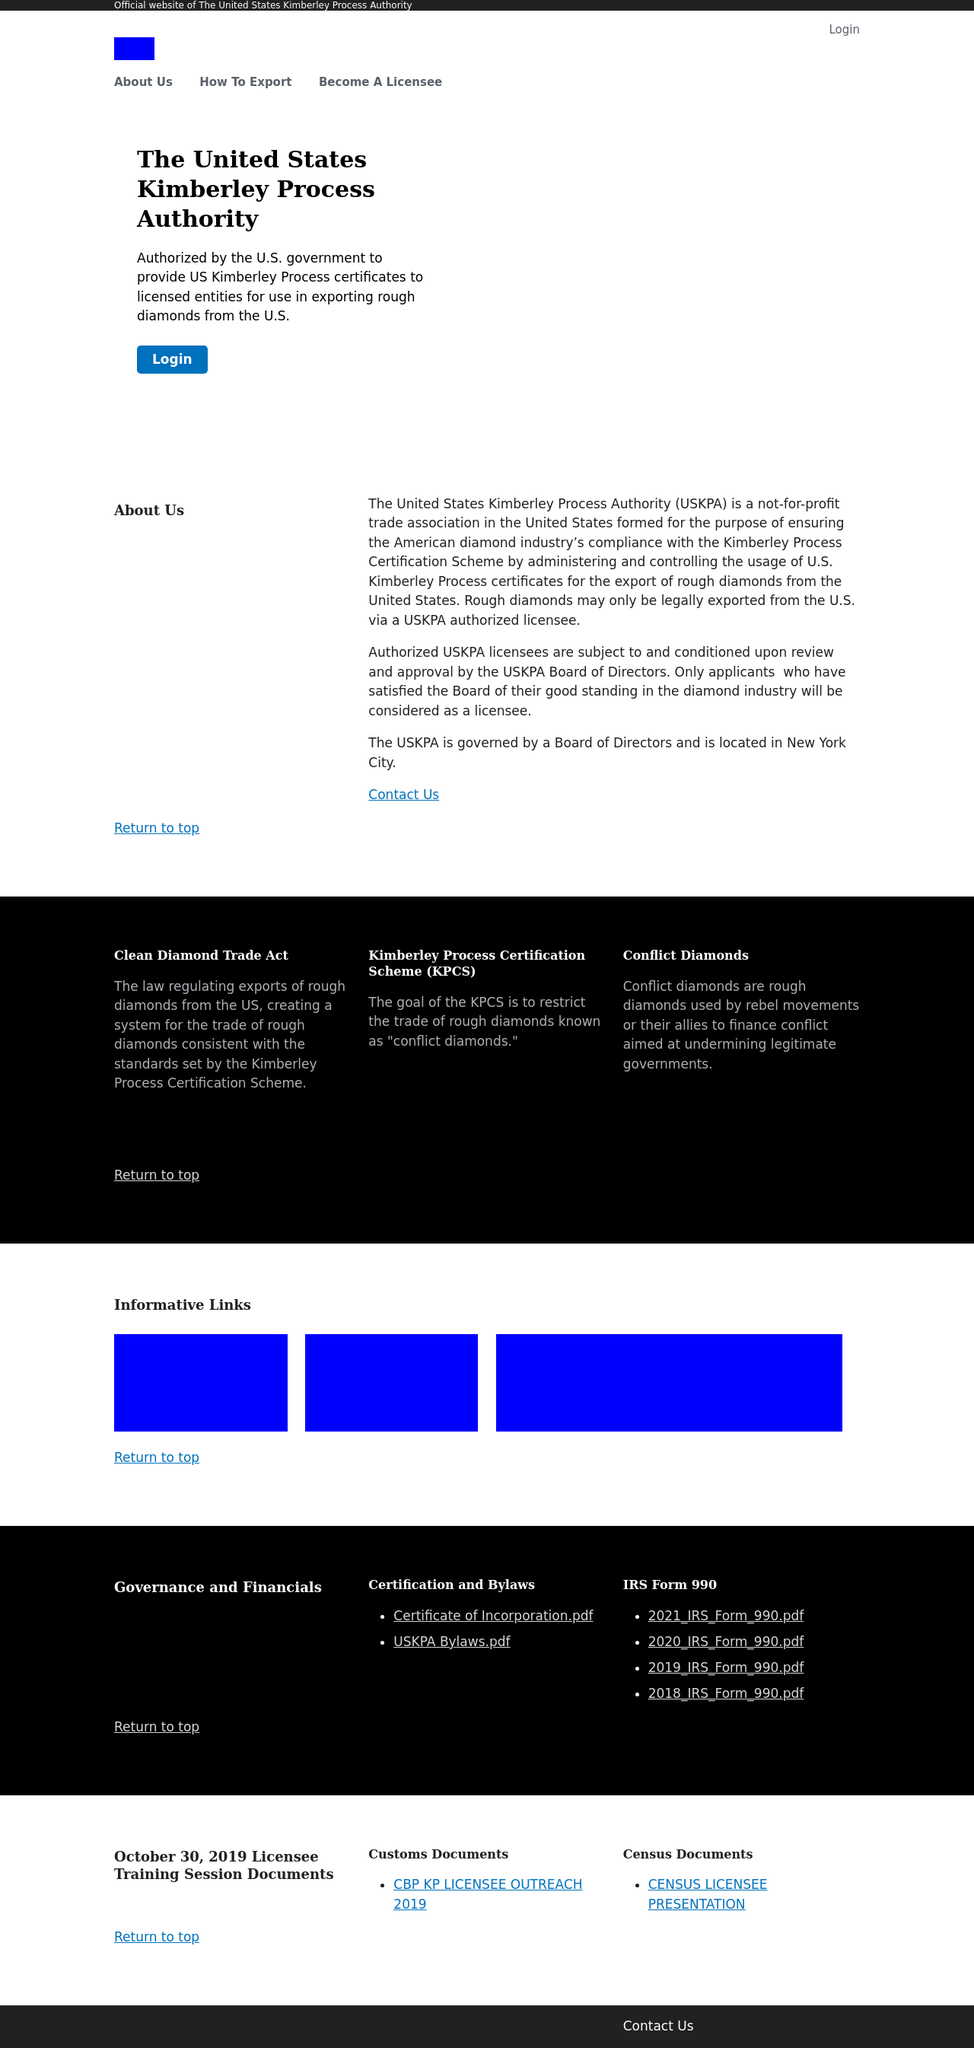What is the main goal of the Kimberley Process Certification Scheme as mentioned on this website? The main goal of the Kimberley Process Certification Scheme (KPCS), as noted on the website, is to prevent the trade of 'conflict diamonds' and to ensure that diamond purchases are not financing violence by rebel movements against recognized governments.  Can you tell me more about the USKPA's governance structure? According to the website, the US Kimberley Process Authority (USKPA) is governed by a Board of Directors and is based in New York City. It operates as a not-for-profit trade association that administers the use of US Kimberley Process certificates for diamond exports. 